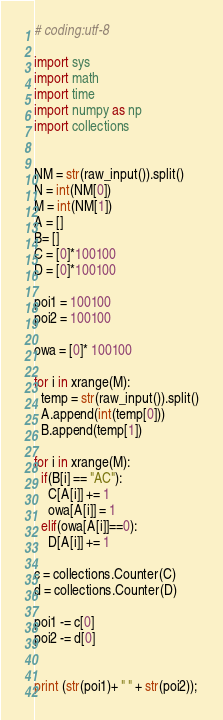<code> <loc_0><loc_0><loc_500><loc_500><_Python_># coding:utf-8

import sys
import math
import time
import numpy as np
import collections


NM = str(raw_input()).split()
N = int(NM[0])
M = int(NM[1])
A = []
B= []
C = [0]*100100
D = [0]*100100

poi1 = 100100
poi2 = 100100

owa = [0]* 100100

for i in xrange(M):
  temp = str(raw_input()).split()
  A.append(int(temp[0]))
  B.append(temp[1])

for i in xrange(M):
  if(B[i] == "AC"):
    C[A[i]] += 1
    owa[A[i]] = 1
  elif(owa[A[i]]==0):
    D[A[i]] += 1

c = collections.Counter(C)
d = collections.Counter(D)

poi1 -= c[0]
poi2 -= d[0]


print (str(poi1)+ " " + str(poi2));
</code> 